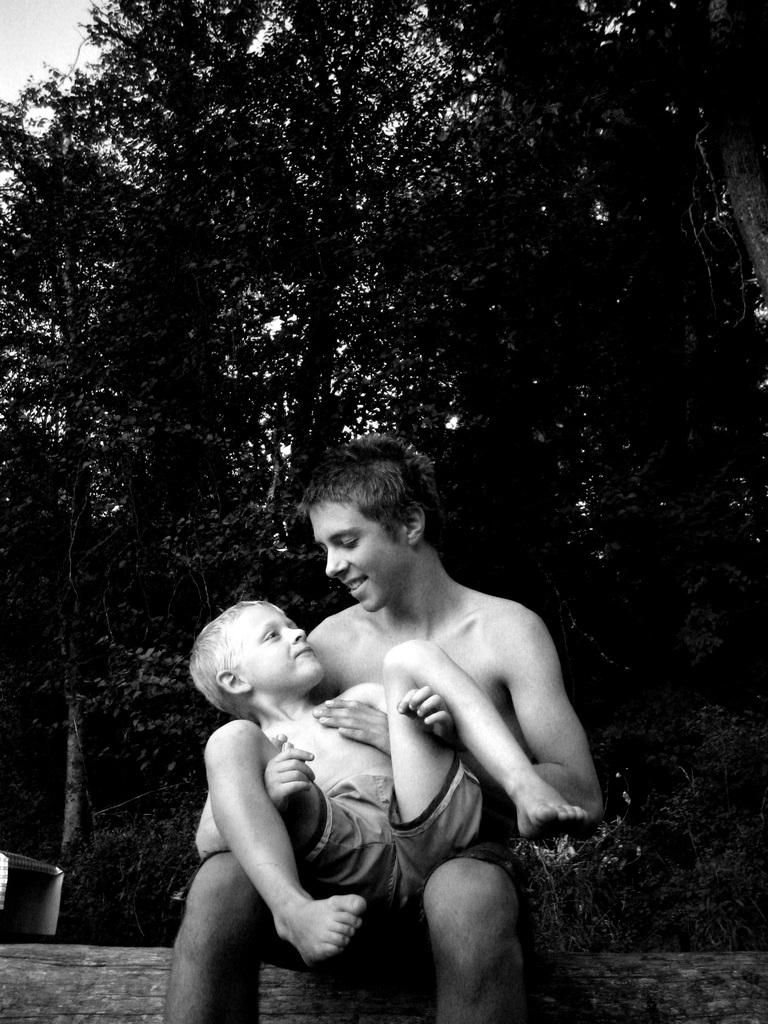Who is present in the image? There is a man and a kid in the image. What can be seen in the background of the image? There are trees in the background of the image. What part of the sky is visible in the image? The sky is visible at the top left of the image. What type of quiver can be seen on the man's back in the image? There is no quiver present on the man's back in the image. How many kittens are playing with the kid in the image? There are no kittens present in the image; it only features a man and a kid. 